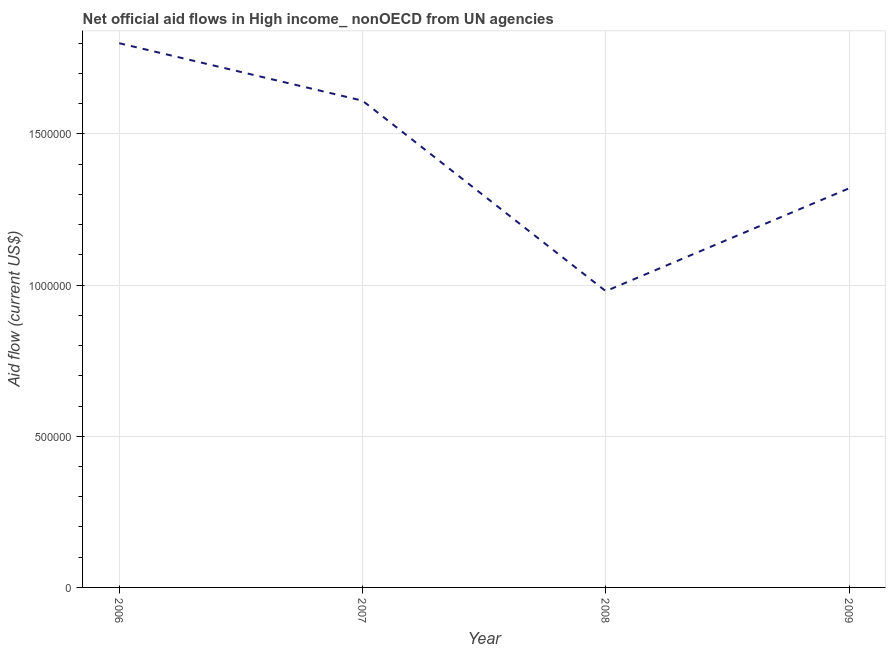What is the net official flows from un agencies in 2006?
Offer a very short reply. 1.80e+06. Across all years, what is the maximum net official flows from un agencies?
Make the answer very short. 1.80e+06. Across all years, what is the minimum net official flows from un agencies?
Provide a short and direct response. 9.80e+05. In which year was the net official flows from un agencies maximum?
Provide a succinct answer. 2006. What is the sum of the net official flows from un agencies?
Provide a succinct answer. 5.71e+06. What is the difference between the net official flows from un agencies in 2006 and 2007?
Your response must be concise. 1.90e+05. What is the average net official flows from un agencies per year?
Keep it short and to the point. 1.43e+06. What is the median net official flows from un agencies?
Your answer should be compact. 1.46e+06. Do a majority of the years between 2006 and 2007 (inclusive) have net official flows from un agencies greater than 700000 US$?
Your answer should be very brief. Yes. What is the ratio of the net official flows from un agencies in 2006 to that in 2008?
Ensure brevity in your answer.  1.84. Is the difference between the net official flows from un agencies in 2006 and 2009 greater than the difference between any two years?
Provide a short and direct response. No. What is the difference between the highest and the second highest net official flows from un agencies?
Make the answer very short. 1.90e+05. Is the sum of the net official flows from un agencies in 2006 and 2007 greater than the maximum net official flows from un agencies across all years?
Ensure brevity in your answer.  Yes. What is the difference between the highest and the lowest net official flows from un agencies?
Provide a succinct answer. 8.20e+05. Does the net official flows from un agencies monotonically increase over the years?
Provide a short and direct response. No. How many years are there in the graph?
Give a very brief answer. 4. What is the difference between two consecutive major ticks on the Y-axis?
Your response must be concise. 5.00e+05. Does the graph contain grids?
Make the answer very short. Yes. What is the title of the graph?
Your answer should be very brief. Net official aid flows in High income_ nonOECD from UN agencies. What is the label or title of the X-axis?
Keep it short and to the point. Year. What is the label or title of the Y-axis?
Your response must be concise. Aid flow (current US$). What is the Aid flow (current US$) of 2006?
Your answer should be compact. 1.80e+06. What is the Aid flow (current US$) in 2007?
Provide a succinct answer. 1.61e+06. What is the Aid flow (current US$) in 2008?
Offer a terse response. 9.80e+05. What is the Aid flow (current US$) of 2009?
Your answer should be very brief. 1.32e+06. What is the difference between the Aid flow (current US$) in 2006 and 2008?
Offer a very short reply. 8.20e+05. What is the difference between the Aid flow (current US$) in 2006 and 2009?
Your answer should be very brief. 4.80e+05. What is the difference between the Aid flow (current US$) in 2007 and 2008?
Provide a succinct answer. 6.30e+05. What is the ratio of the Aid flow (current US$) in 2006 to that in 2007?
Make the answer very short. 1.12. What is the ratio of the Aid flow (current US$) in 2006 to that in 2008?
Provide a succinct answer. 1.84. What is the ratio of the Aid flow (current US$) in 2006 to that in 2009?
Ensure brevity in your answer.  1.36. What is the ratio of the Aid flow (current US$) in 2007 to that in 2008?
Keep it short and to the point. 1.64. What is the ratio of the Aid flow (current US$) in 2007 to that in 2009?
Make the answer very short. 1.22. What is the ratio of the Aid flow (current US$) in 2008 to that in 2009?
Make the answer very short. 0.74. 